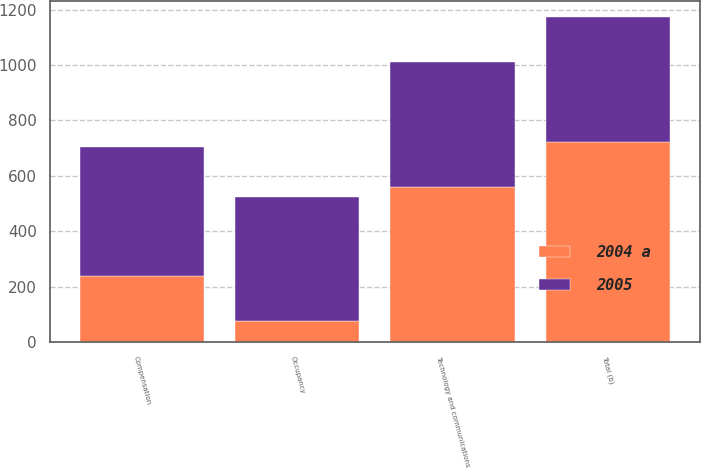Convert chart to OTSL. <chart><loc_0><loc_0><loc_500><loc_500><stacked_bar_chart><ecel><fcel>Compensation<fcel>Occupancy<fcel>Technology and communications<fcel>Total (b)<nl><fcel>2004 a<fcel>238<fcel>77<fcel>561<fcel>722<nl><fcel>2005<fcel>467<fcel>448<fcel>450<fcel>450<nl></chart> 